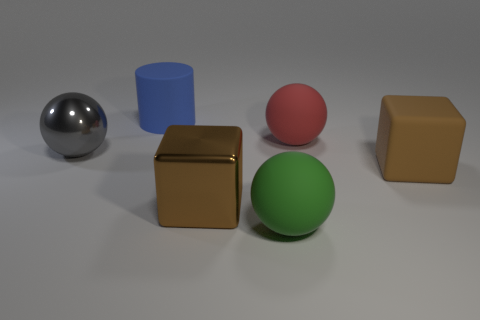Subtract all rubber spheres. How many spheres are left? 1 Subtract all gray spheres. How many spheres are left? 2 Subtract 3 spheres. How many spheres are left? 0 Subtract all cyan balls. Subtract all cyan cylinders. How many balls are left? 3 Subtract all yellow blocks. How many yellow balls are left? 0 Subtract all large blue rubber blocks. Subtract all big brown blocks. How many objects are left? 4 Add 6 brown matte things. How many brown matte things are left? 7 Add 3 tiny yellow things. How many tiny yellow things exist? 3 Add 1 shiny cubes. How many objects exist? 7 Subtract 0 cyan cubes. How many objects are left? 6 